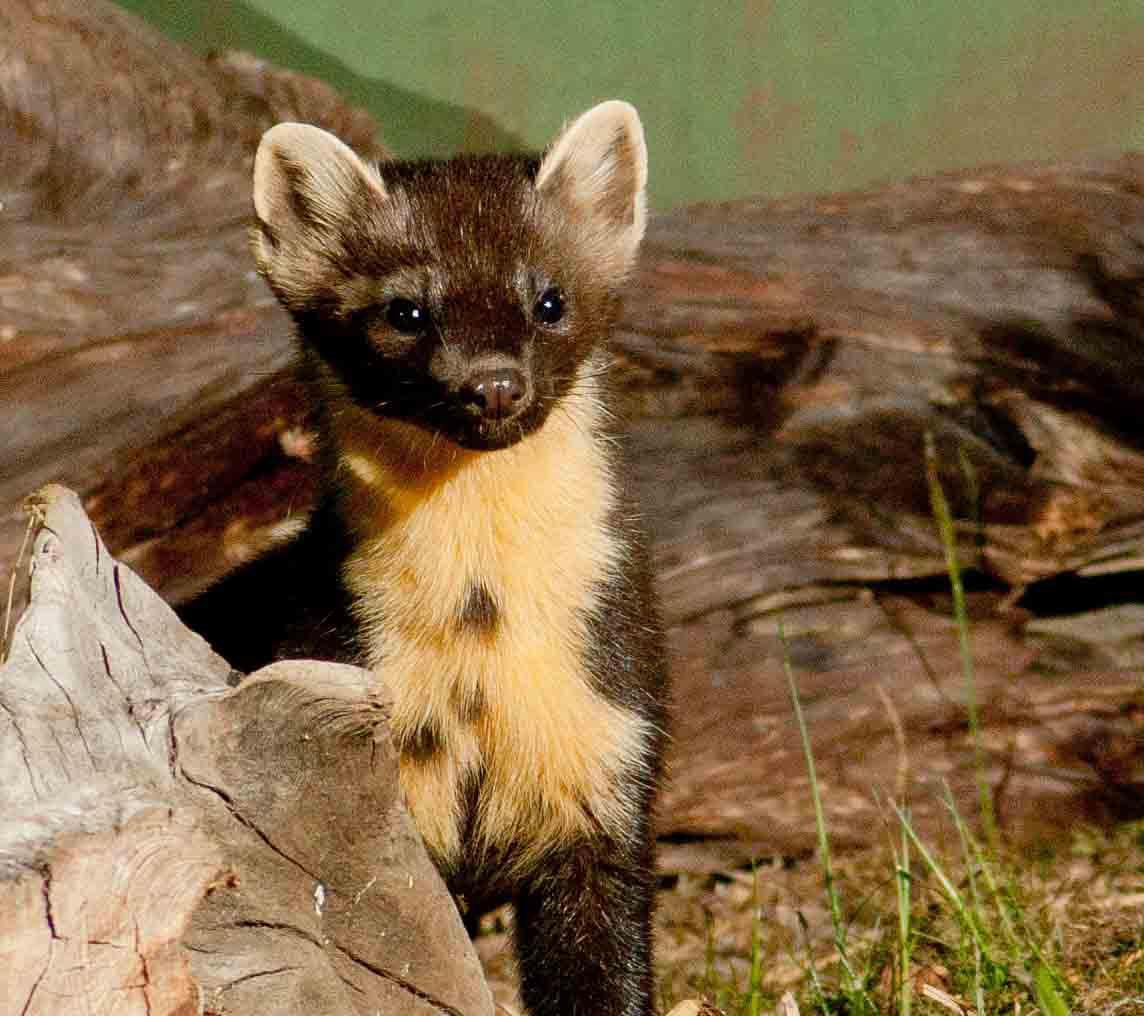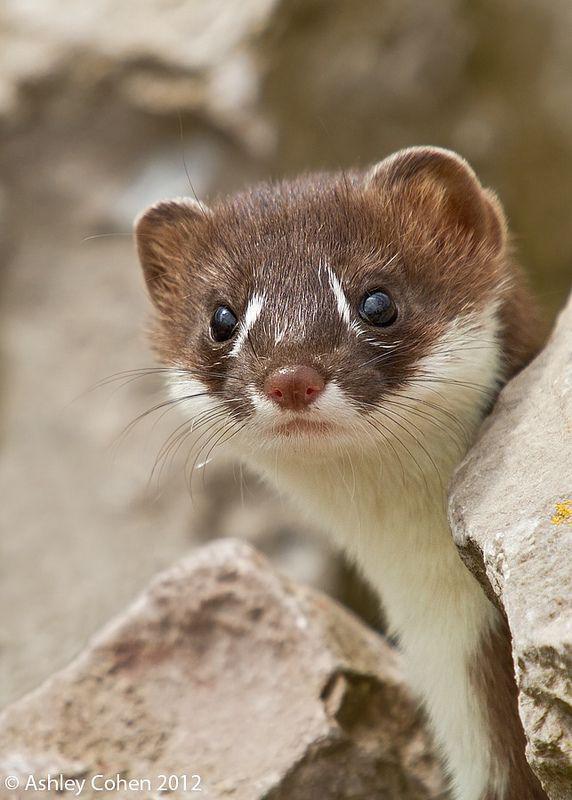The first image is the image on the left, the second image is the image on the right. Assess this claim about the two images: "Each image shows a single ferret, with its head held upright.". Correct or not? Answer yes or no. Yes. The first image is the image on the left, the second image is the image on the right. Analyze the images presented: Is the assertion "A single animal is poking its head out from the ground." valid? Answer yes or no. No. 